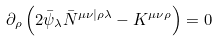Convert formula to latex. <formula><loc_0><loc_0><loc_500><loc_500>\partial _ { \rho } \left ( 2 \bar { \psi } _ { \lambda } \bar { N } ^ { \mu \nu | \rho \lambda } - K ^ { \mu \nu \rho } \right ) = 0</formula> 